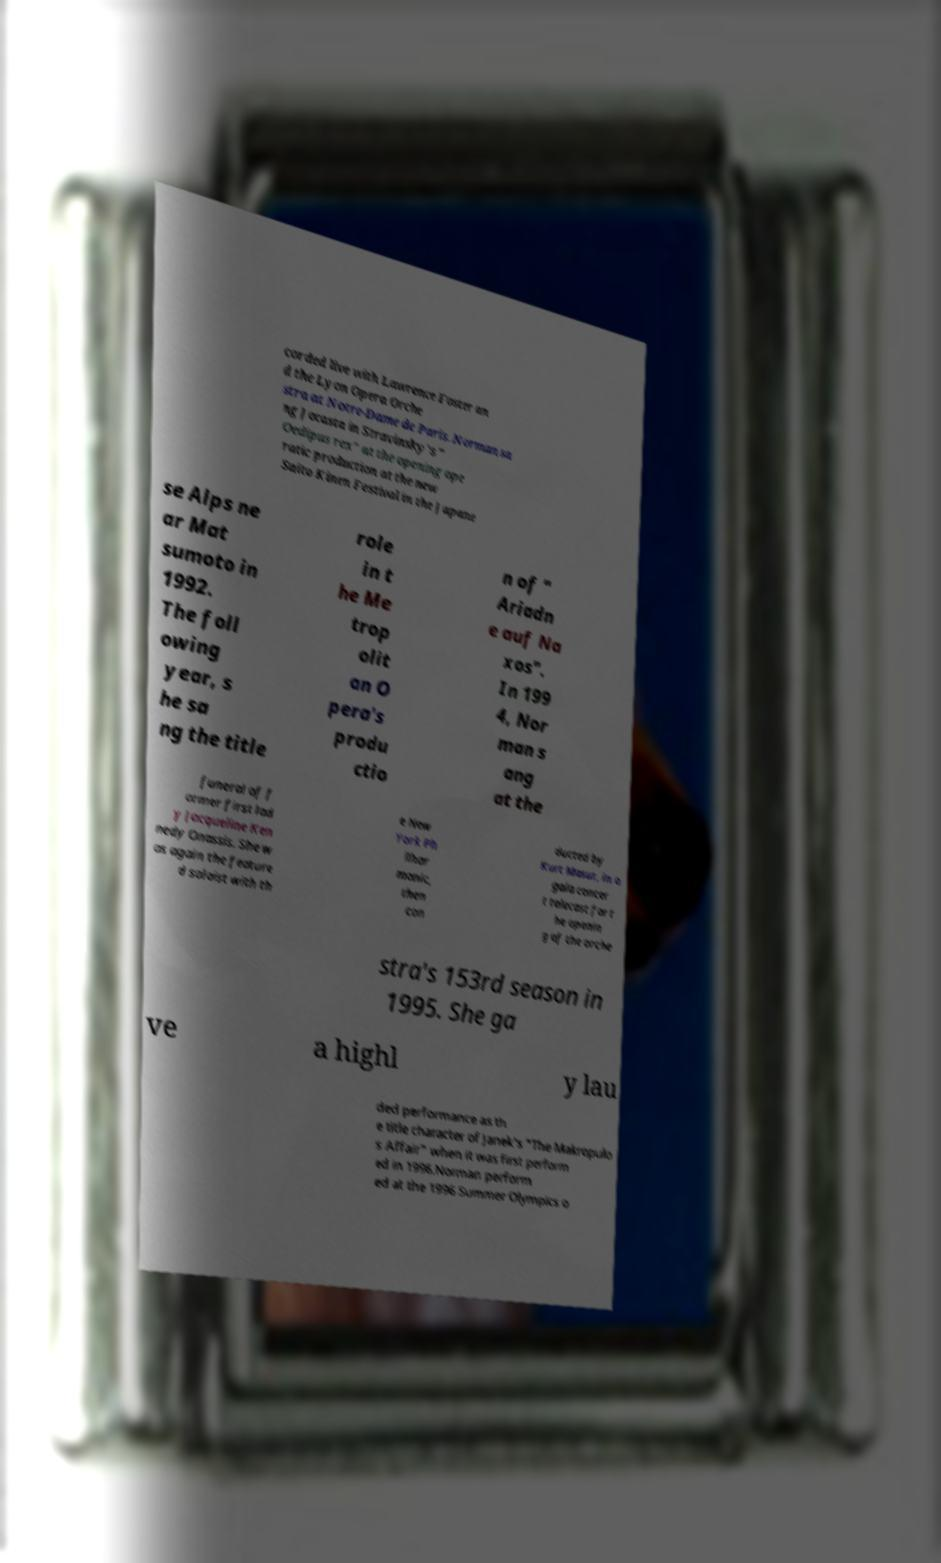Please read and relay the text visible in this image. What does it say? corded live with Lawrence Foster an d the Lyon Opera Orche stra at Notre-Dame de Paris. Norman sa ng Jocasta in Stravinsky's " Oedipus rex" at the opening ope ratic production at the new Saito Kinen Festival in the Japane se Alps ne ar Mat sumoto in 1992. The foll owing year, s he sa ng the title role in t he Me trop olit an O pera's produ ctio n of " Ariadn e auf Na xos". In 199 4, Nor man s ang at the funeral of f ormer first lad y Jacqueline Ken nedy Onassis. She w as again the feature d soloist with th e New York Ph ilhar monic, then con ducted by Kurt Masur, in a gala concer t telecast for t he openin g of the orche stra's 153rd season in 1995. She ga ve a highl y lau ded performance as th e title character of Janek's "The Makropulo s Affair" when it was first perform ed in 1996.Norman perform ed at the 1996 Summer Olympics o 